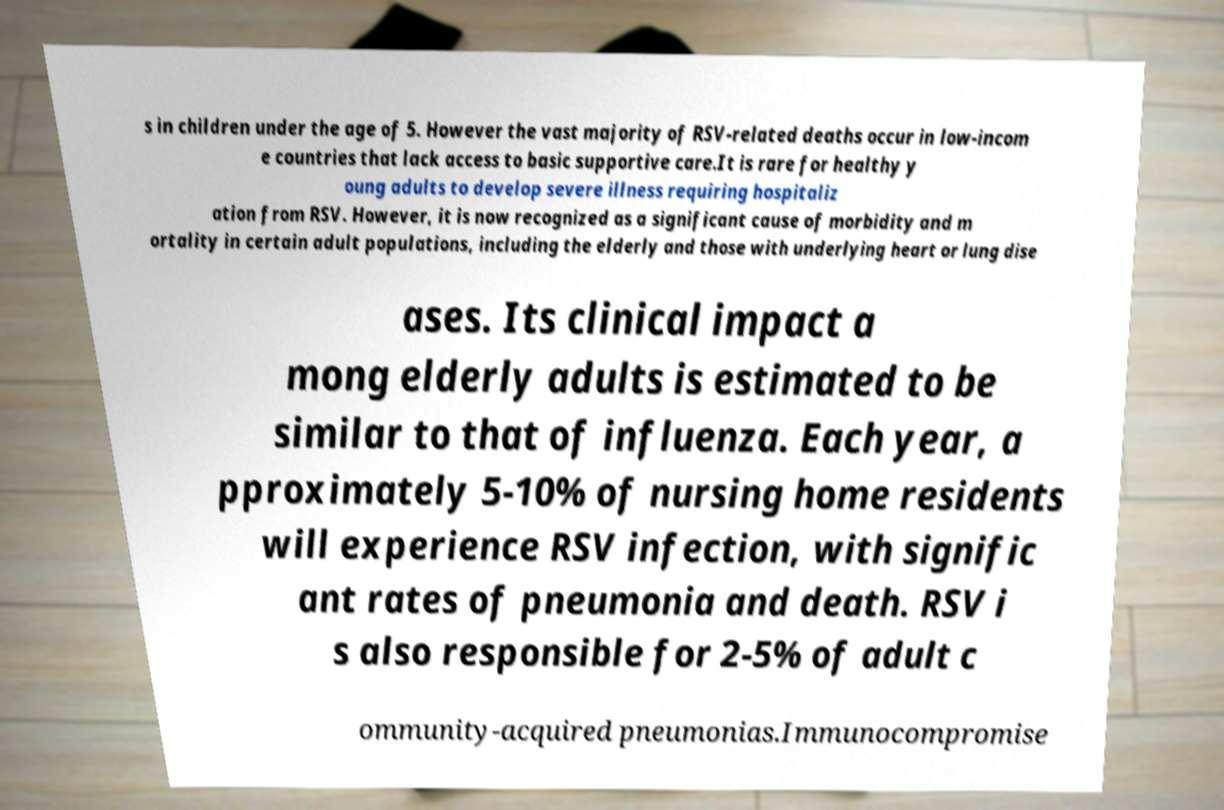Can you accurately transcribe the text from the provided image for me? s in children under the age of 5. However the vast majority of RSV-related deaths occur in low-incom e countries that lack access to basic supportive care.It is rare for healthy y oung adults to develop severe illness requiring hospitaliz ation from RSV. However, it is now recognized as a significant cause of morbidity and m ortality in certain adult populations, including the elderly and those with underlying heart or lung dise ases. Its clinical impact a mong elderly adults is estimated to be similar to that of influenza. Each year, a pproximately 5-10% of nursing home residents will experience RSV infection, with signific ant rates of pneumonia and death. RSV i s also responsible for 2-5% of adult c ommunity-acquired pneumonias.Immunocompromise 